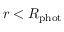Convert formula to latex. <formula><loc_0><loc_0><loc_500><loc_500>r < R _ { p h o t }</formula> 